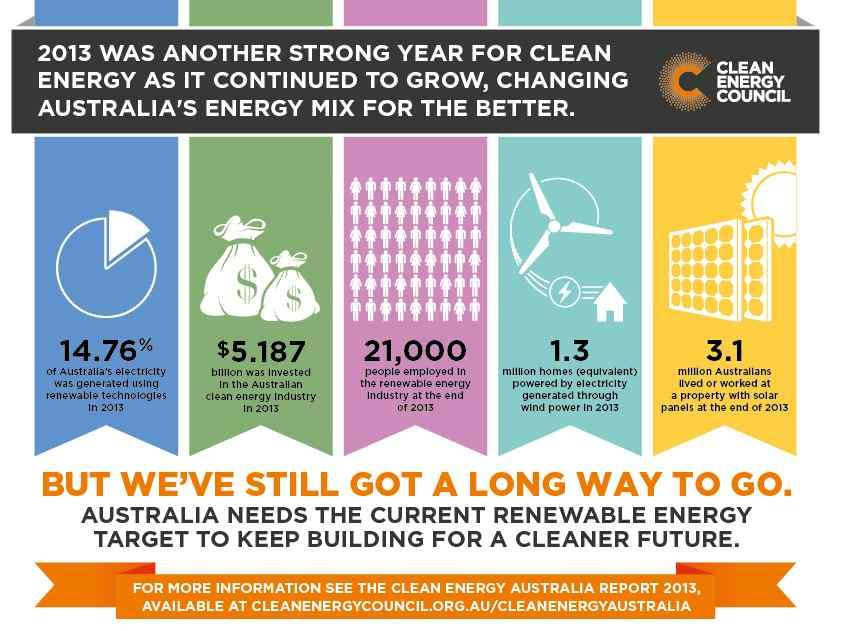List a handful of essential elements in this visual. Out of the 1.3 million houses, how many were powered by wind energy? The answer is 1.3 million. 